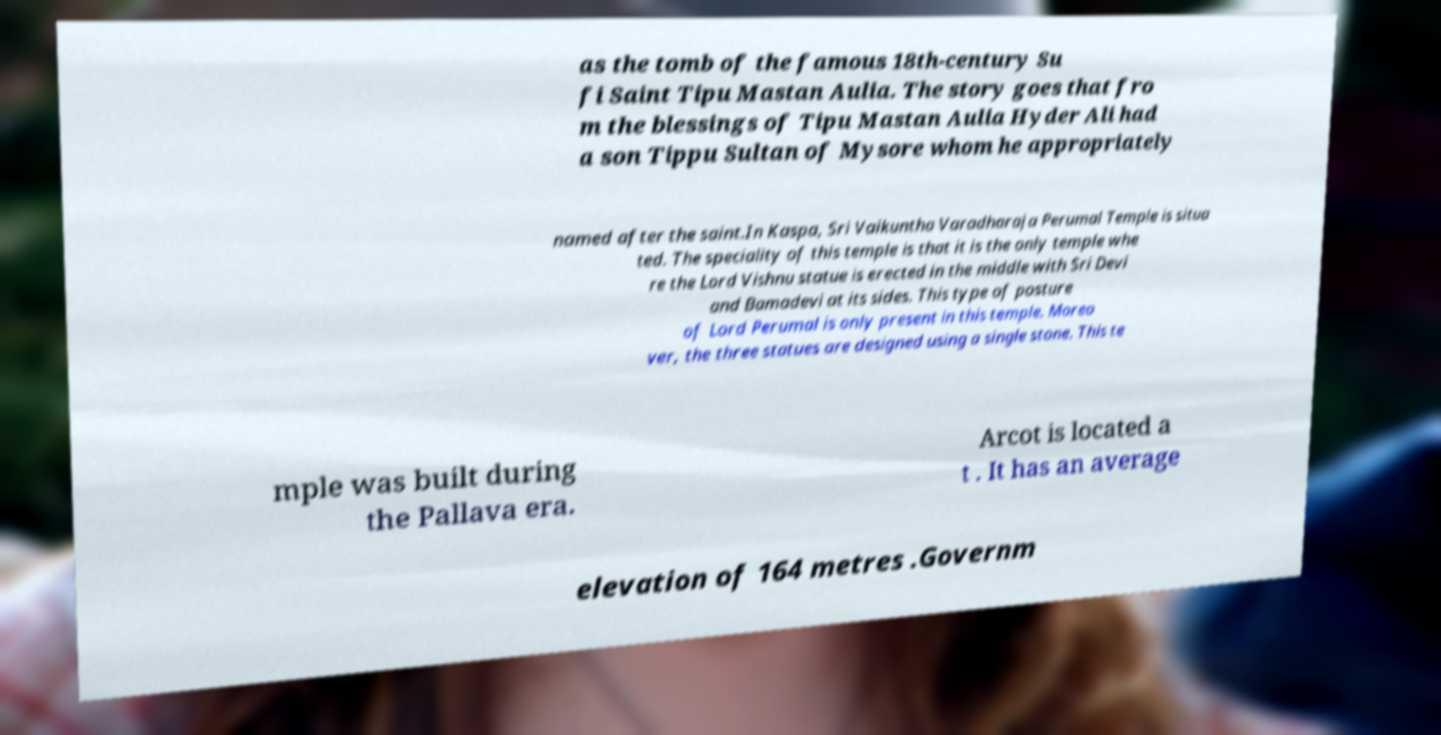For documentation purposes, I need the text within this image transcribed. Could you provide that? as the tomb of the famous 18th-century Su fi Saint Tipu Mastan Aulia. The story goes that fro m the blessings of Tipu Mastan Aulia Hyder Ali had a son Tippu Sultan of Mysore whom he appropriately named after the saint.In Kaspa, Sri Vaikuntha Varadharaja Perumal Temple is situa ted. The speciality of this temple is that it is the only temple whe re the Lord Vishnu statue is erected in the middle with Sri Devi and Bamadevi at its sides. This type of posture of Lord Perumal is only present in this temple. Moreo ver, the three statues are designed using a single stone. This te mple was built during the Pallava era. Arcot is located a t . It has an average elevation of 164 metres .Governm 